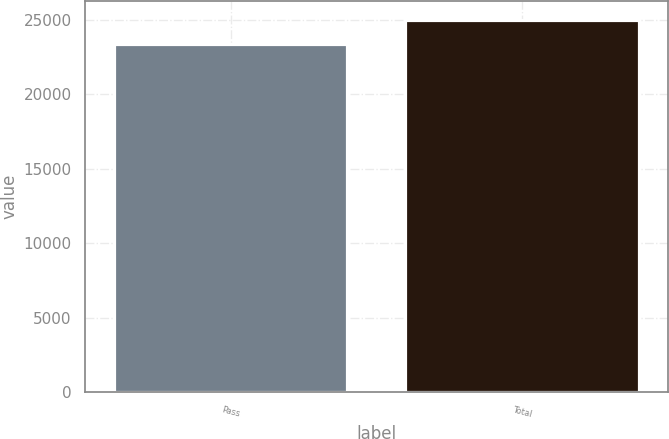Convert chart. <chart><loc_0><loc_0><loc_500><loc_500><bar_chart><fcel>Pass<fcel>Total<nl><fcel>23409<fcel>25025<nl></chart> 